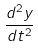<formula> <loc_0><loc_0><loc_500><loc_500>\frac { d ^ { 2 } y } { d t ^ { 2 } }</formula> 